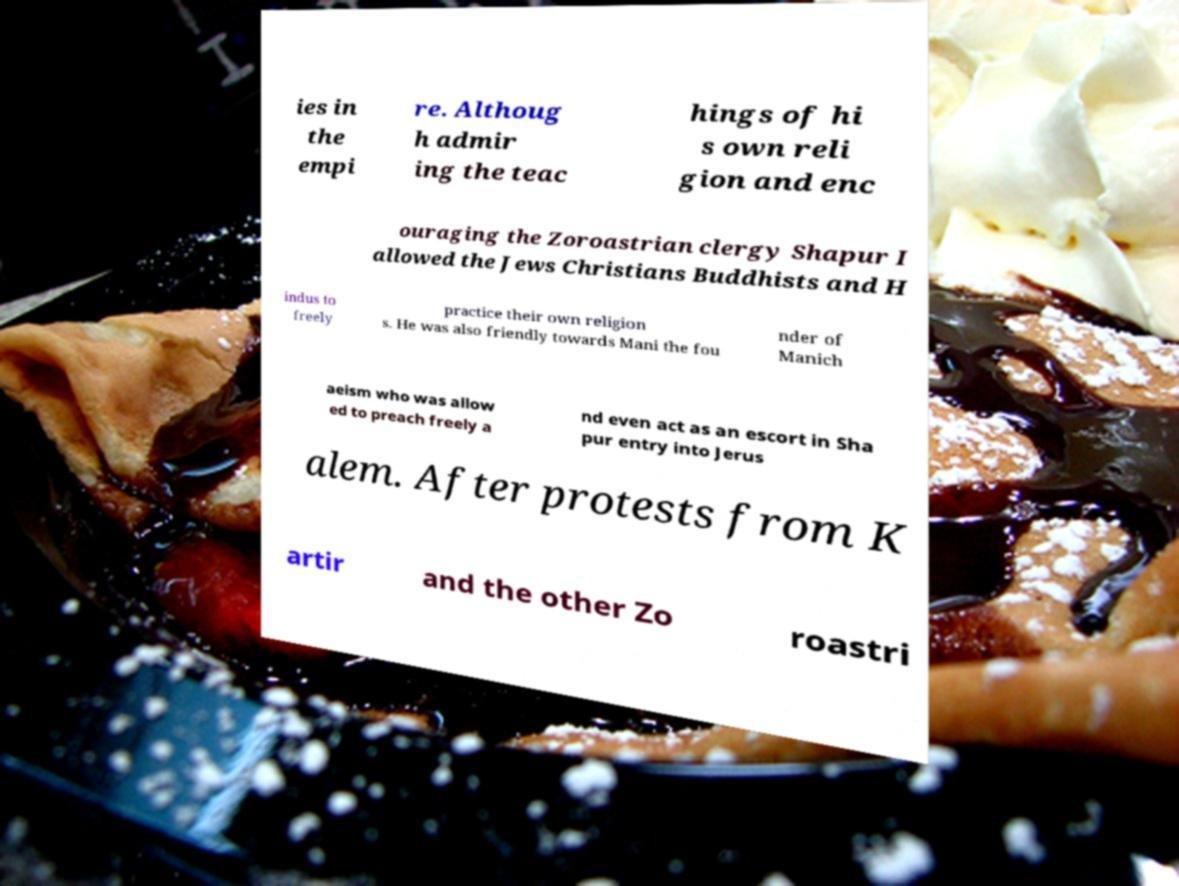Please read and relay the text visible in this image. What does it say? ies in the empi re. Althoug h admir ing the teac hings of hi s own reli gion and enc ouraging the Zoroastrian clergy Shapur I allowed the Jews Christians Buddhists and H indus to freely practice their own religion s. He was also friendly towards Mani the fou nder of Manich aeism who was allow ed to preach freely a nd even act as an escort in Sha pur entry into Jerus alem. After protests from K artir and the other Zo roastri 